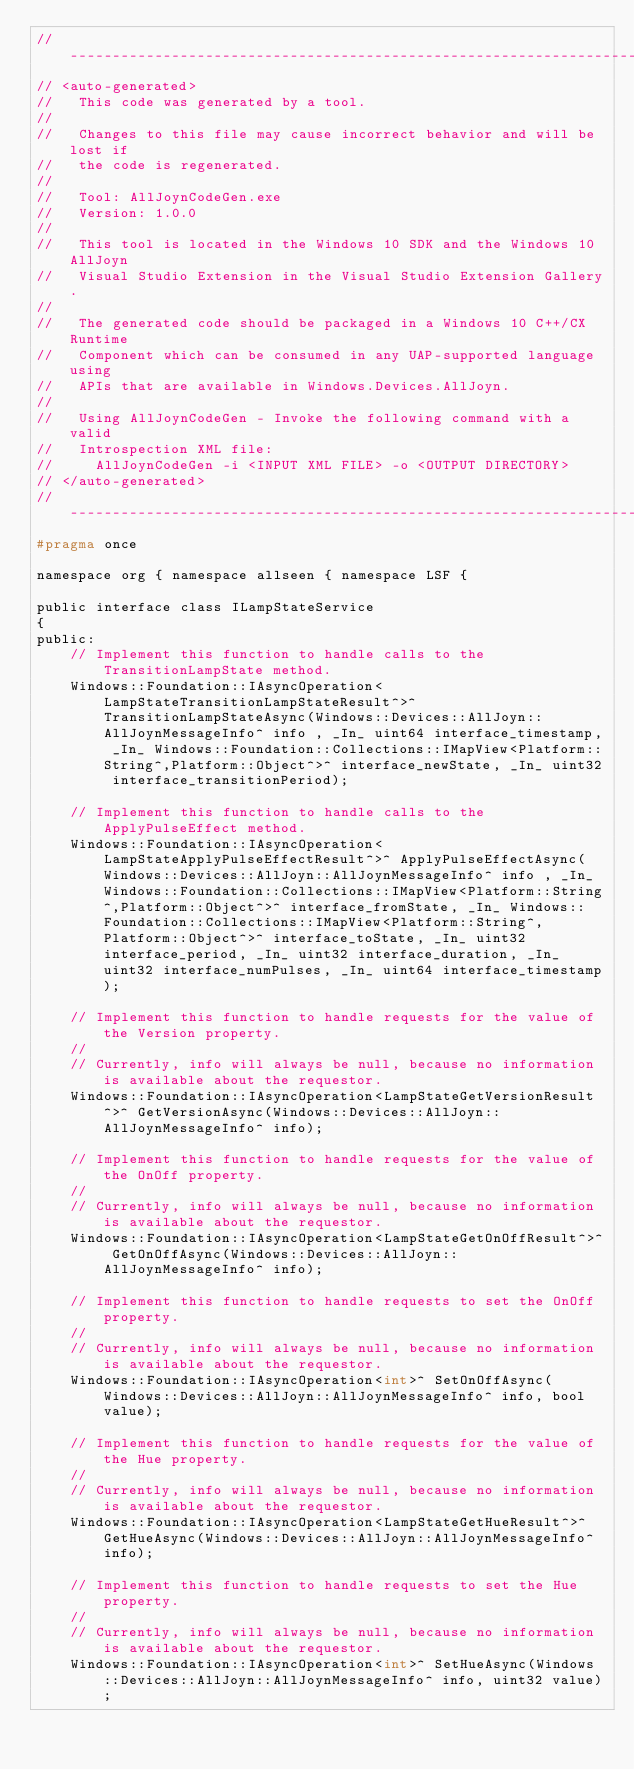<code> <loc_0><loc_0><loc_500><loc_500><_C_>//-----------------------------------------------------------------------------
// <auto-generated> 
//   This code was generated by a tool. 
// 
//   Changes to this file may cause incorrect behavior and will be lost if  
//   the code is regenerated.
//
//   Tool: AllJoynCodeGen.exe
//   Version: 1.0.0
//
//   This tool is located in the Windows 10 SDK and the Windows 10 AllJoyn 
//   Visual Studio Extension in the Visual Studio Extension Gallery.  
//
//   The generated code should be packaged in a Windows 10 C++/CX Runtime  
//   Component which can be consumed in any UAP-supported language using 
//   APIs that are available in Windows.Devices.AllJoyn.
//
//   Using AllJoynCodeGen - Invoke the following command with a valid 
//   Introspection XML file:
//     AllJoynCodeGen -i <INPUT XML FILE> -o <OUTPUT DIRECTORY>
// </auto-generated>
//-----------------------------------------------------------------------------
#pragma once

namespace org { namespace allseen { namespace LSF {

public interface class ILampStateService
{
public:
    // Implement this function to handle calls to the TransitionLampState method.
    Windows::Foundation::IAsyncOperation<LampStateTransitionLampStateResult^>^ TransitionLampStateAsync(Windows::Devices::AllJoyn::AllJoynMessageInfo^ info , _In_ uint64 interface_timestamp, _In_ Windows::Foundation::Collections::IMapView<Platform::String^,Platform::Object^>^ interface_newState, _In_ uint32 interface_transitionPeriod);

    // Implement this function to handle calls to the ApplyPulseEffect method.
    Windows::Foundation::IAsyncOperation<LampStateApplyPulseEffectResult^>^ ApplyPulseEffectAsync(Windows::Devices::AllJoyn::AllJoynMessageInfo^ info , _In_ Windows::Foundation::Collections::IMapView<Platform::String^,Platform::Object^>^ interface_fromState, _In_ Windows::Foundation::Collections::IMapView<Platform::String^,Platform::Object^>^ interface_toState, _In_ uint32 interface_period, _In_ uint32 interface_duration, _In_ uint32 interface_numPulses, _In_ uint64 interface_timestamp);

    // Implement this function to handle requests for the value of the Version property.
    //
    // Currently, info will always be null, because no information is available about the requestor.
    Windows::Foundation::IAsyncOperation<LampStateGetVersionResult^>^ GetVersionAsync(Windows::Devices::AllJoyn::AllJoynMessageInfo^ info);

    // Implement this function to handle requests for the value of the OnOff property.
    //
    // Currently, info will always be null, because no information is available about the requestor.
    Windows::Foundation::IAsyncOperation<LampStateGetOnOffResult^>^ GetOnOffAsync(Windows::Devices::AllJoyn::AllJoynMessageInfo^ info);

    // Implement this function to handle requests to set the OnOff property.
    //
    // Currently, info will always be null, because no information is available about the requestor.
    Windows::Foundation::IAsyncOperation<int>^ SetOnOffAsync(Windows::Devices::AllJoyn::AllJoynMessageInfo^ info, bool value);

    // Implement this function to handle requests for the value of the Hue property.
    //
    // Currently, info will always be null, because no information is available about the requestor.
    Windows::Foundation::IAsyncOperation<LampStateGetHueResult^>^ GetHueAsync(Windows::Devices::AllJoyn::AllJoynMessageInfo^ info);

    // Implement this function to handle requests to set the Hue property.
    //
    // Currently, info will always be null, because no information is available about the requestor.
    Windows::Foundation::IAsyncOperation<int>^ SetHueAsync(Windows::Devices::AllJoyn::AllJoynMessageInfo^ info, uint32 value);
</code> 